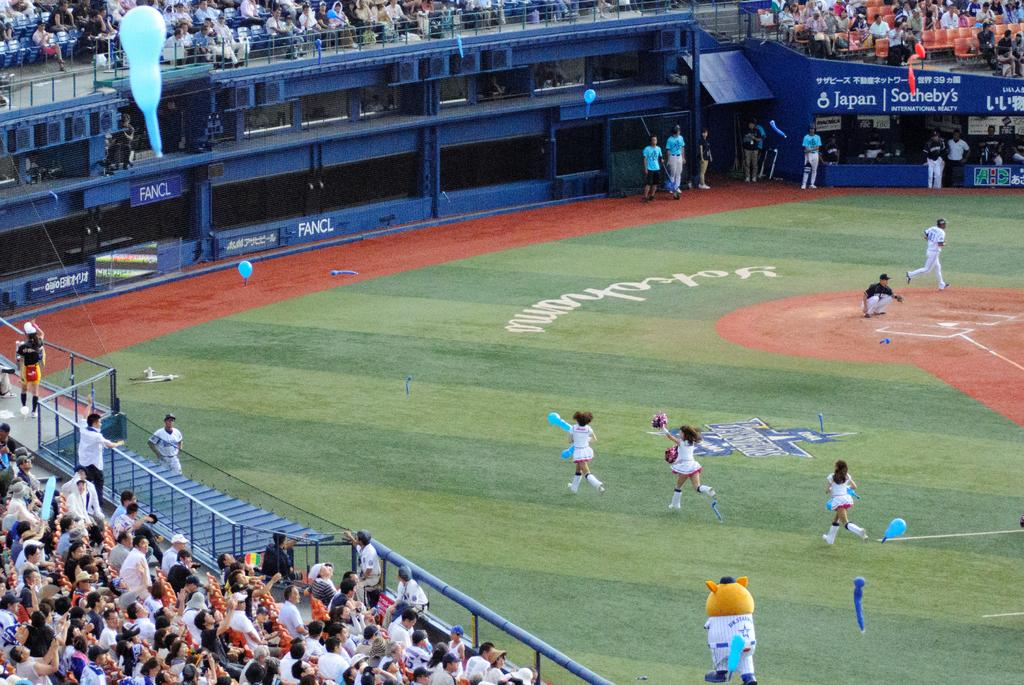Provide a one-sentence caption for the provided image. An advertisement for Sotheby's hangs at a sporting event. 